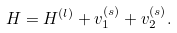<formula> <loc_0><loc_0><loc_500><loc_500>H = H ^ { ( l ) } + v _ { 1 } ^ { ( s ) } + v _ { 2 } ^ { ( s ) } .</formula> 